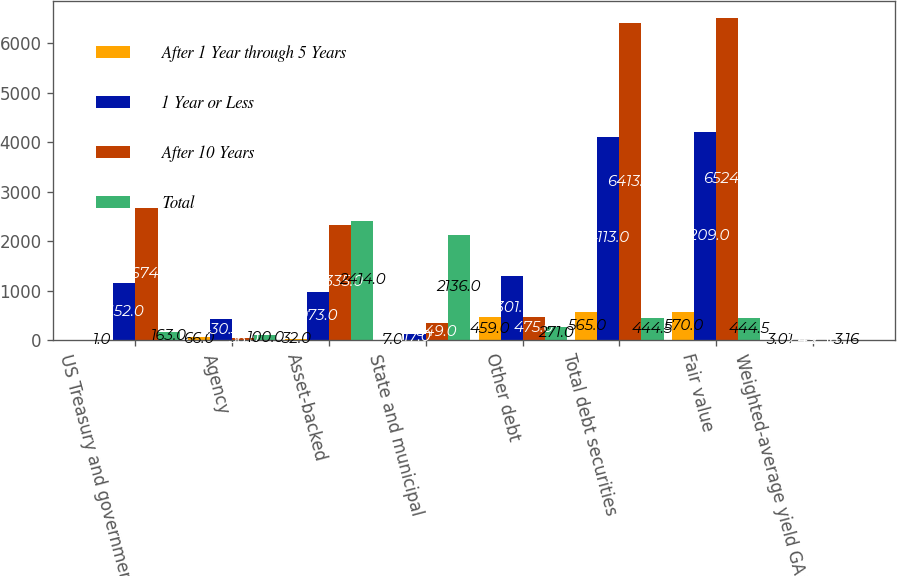Convert chart to OTSL. <chart><loc_0><loc_0><loc_500><loc_500><stacked_bar_chart><ecel><fcel>US Treasury and government<fcel>Agency<fcel>Asset-backed<fcel>State and municipal<fcel>Other debt<fcel>Total debt securities<fcel>Fair value<fcel>Weighted-average yield GAAP<nl><fcel>After 1 Year through 5 Years<fcel>1<fcel>66<fcel>32<fcel>7<fcel>459<fcel>565<fcel>570<fcel>3.01<nl><fcel>1 Year or Less<fcel>1152<fcel>430<fcel>973<fcel>117<fcel>1301<fcel>4113<fcel>4209<fcel>2.49<nl><fcel>After 10 Years<fcel>2674<fcel>36<fcel>2335<fcel>349<fcel>475<fcel>6413<fcel>6524<fcel>2.36<nl><fcel>Total<fcel>163<fcel>100<fcel>2414<fcel>2136<fcel>271<fcel>444.5<fcel>444.5<fcel>3.16<nl></chart> 